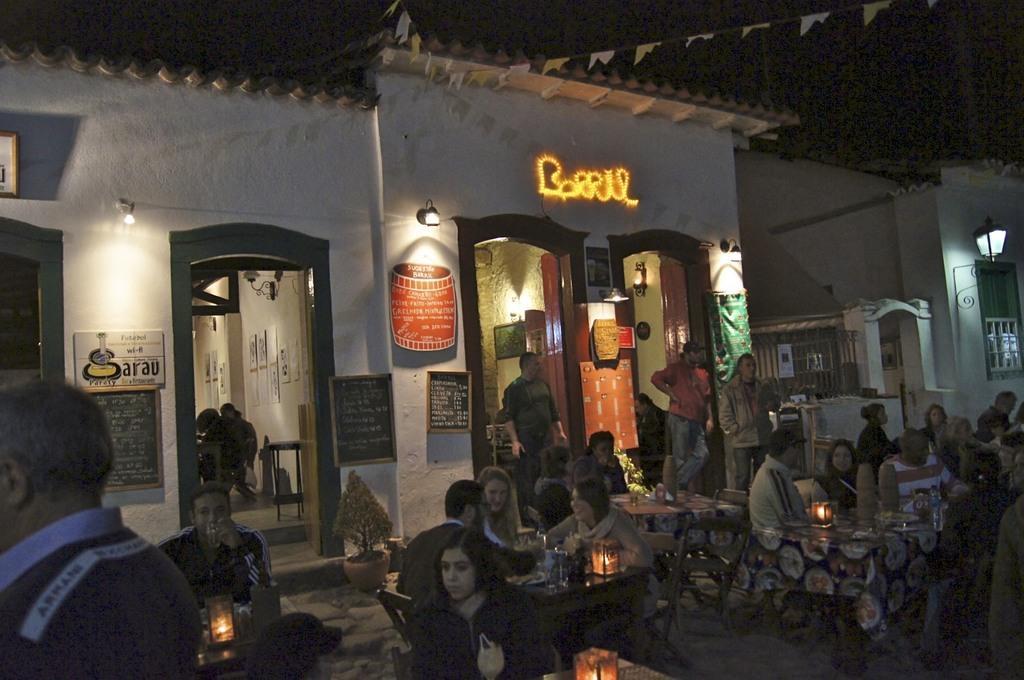Describe this image in one or two sentences. In this picture we can see the boards, lights, posters. We can see the people are sitting on the chairs and few are standing. On the tables we can see the lanterns and few objects. In this picture we can see the houseplants. At the top we can see the roof tiles and the colorful flags. 